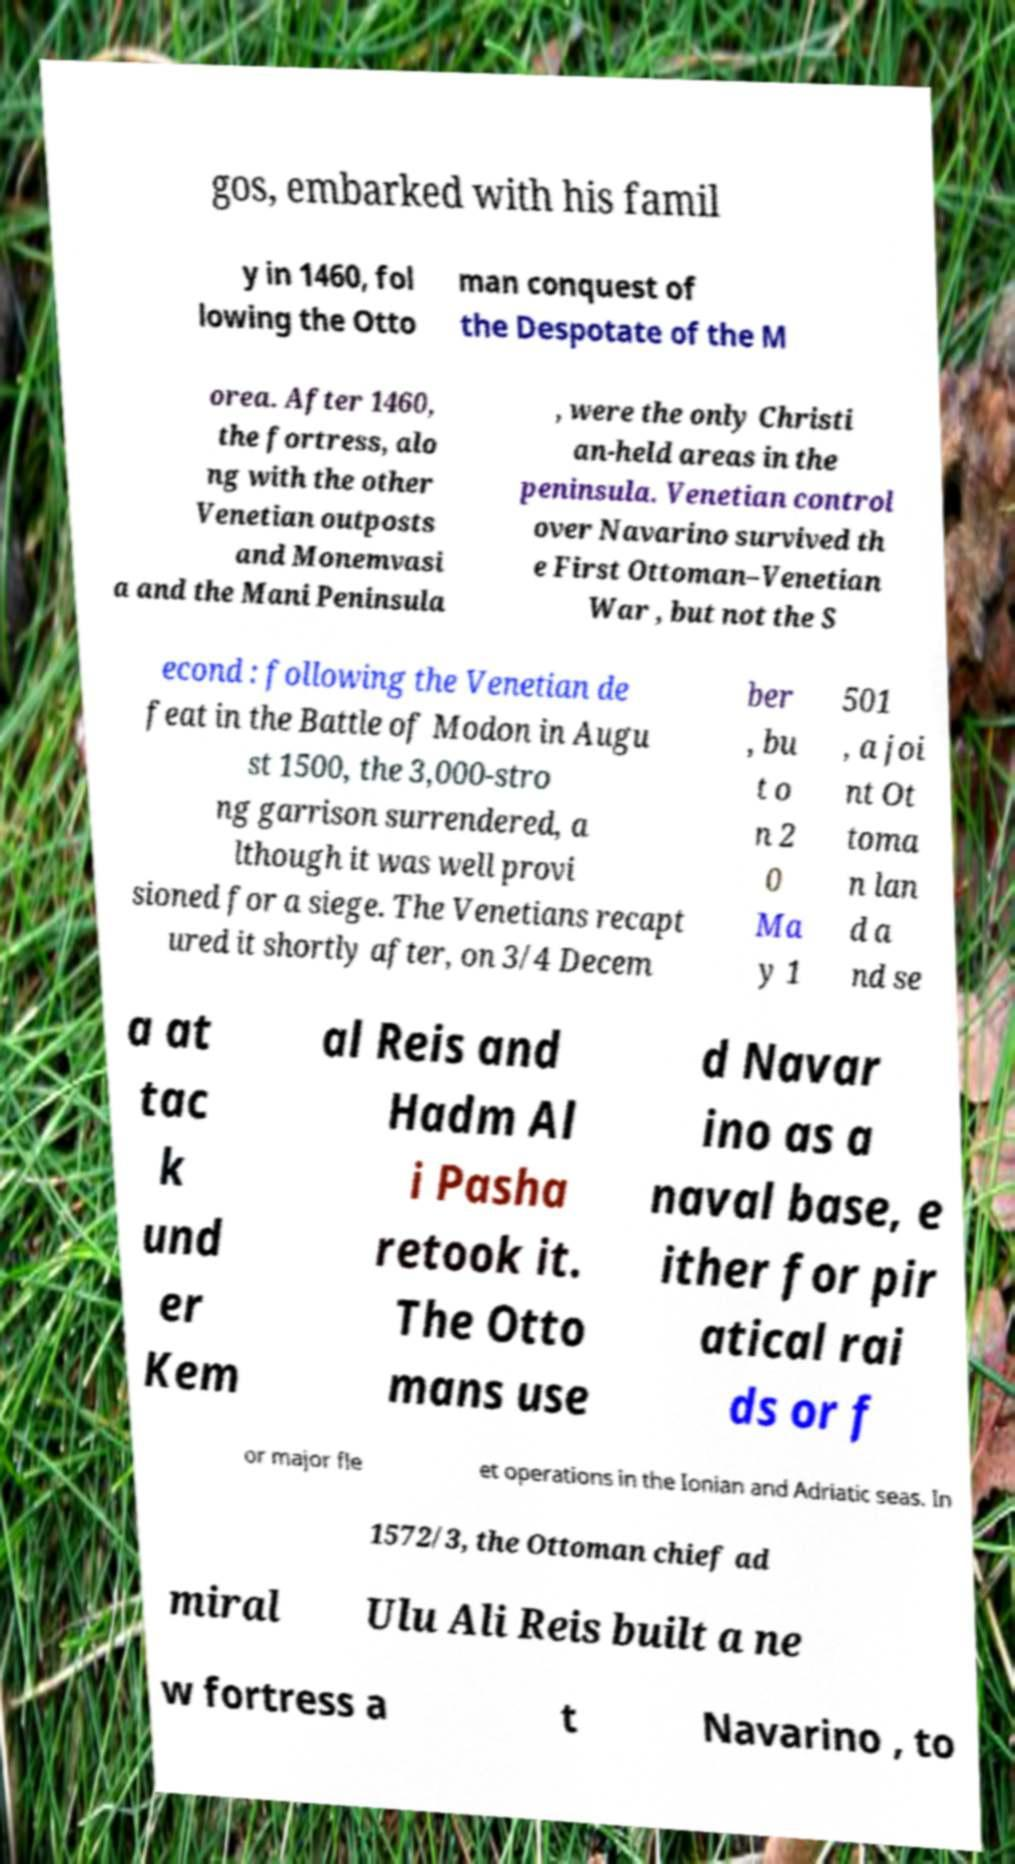For documentation purposes, I need the text within this image transcribed. Could you provide that? gos, embarked with his famil y in 1460, fol lowing the Otto man conquest of the Despotate of the M orea. After 1460, the fortress, alo ng with the other Venetian outposts and Monemvasi a and the Mani Peninsula , were the only Christi an-held areas in the peninsula. Venetian control over Navarino survived th e First Ottoman–Venetian War , but not the S econd : following the Venetian de feat in the Battle of Modon in Augu st 1500, the 3,000-stro ng garrison surrendered, a lthough it was well provi sioned for a siege. The Venetians recapt ured it shortly after, on 3/4 Decem ber , bu t o n 2 0 Ma y 1 501 , a joi nt Ot toma n lan d a nd se a at tac k und er Kem al Reis and Hadm Al i Pasha retook it. The Otto mans use d Navar ino as a naval base, e ither for pir atical rai ds or f or major fle et operations in the Ionian and Adriatic seas. In 1572/3, the Ottoman chief ad miral Ulu Ali Reis built a ne w fortress a t Navarino , to 